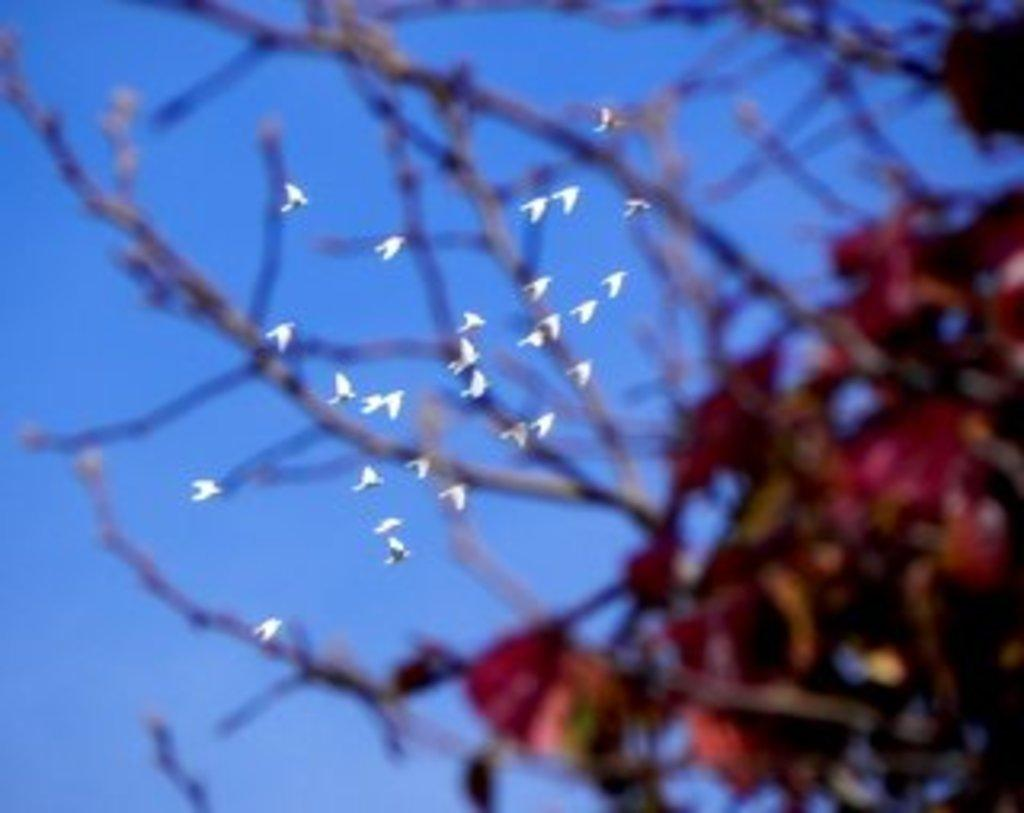What type of vegetation is visible in the image? There are branches of a tree in the image. What is happening in the sky in the image? There are birds flying in the sky in the image. What type of popcorn is being used to support the birds in the image? There is no popcorn or support for the birds in the image; the birds are simply flying in the sky. 